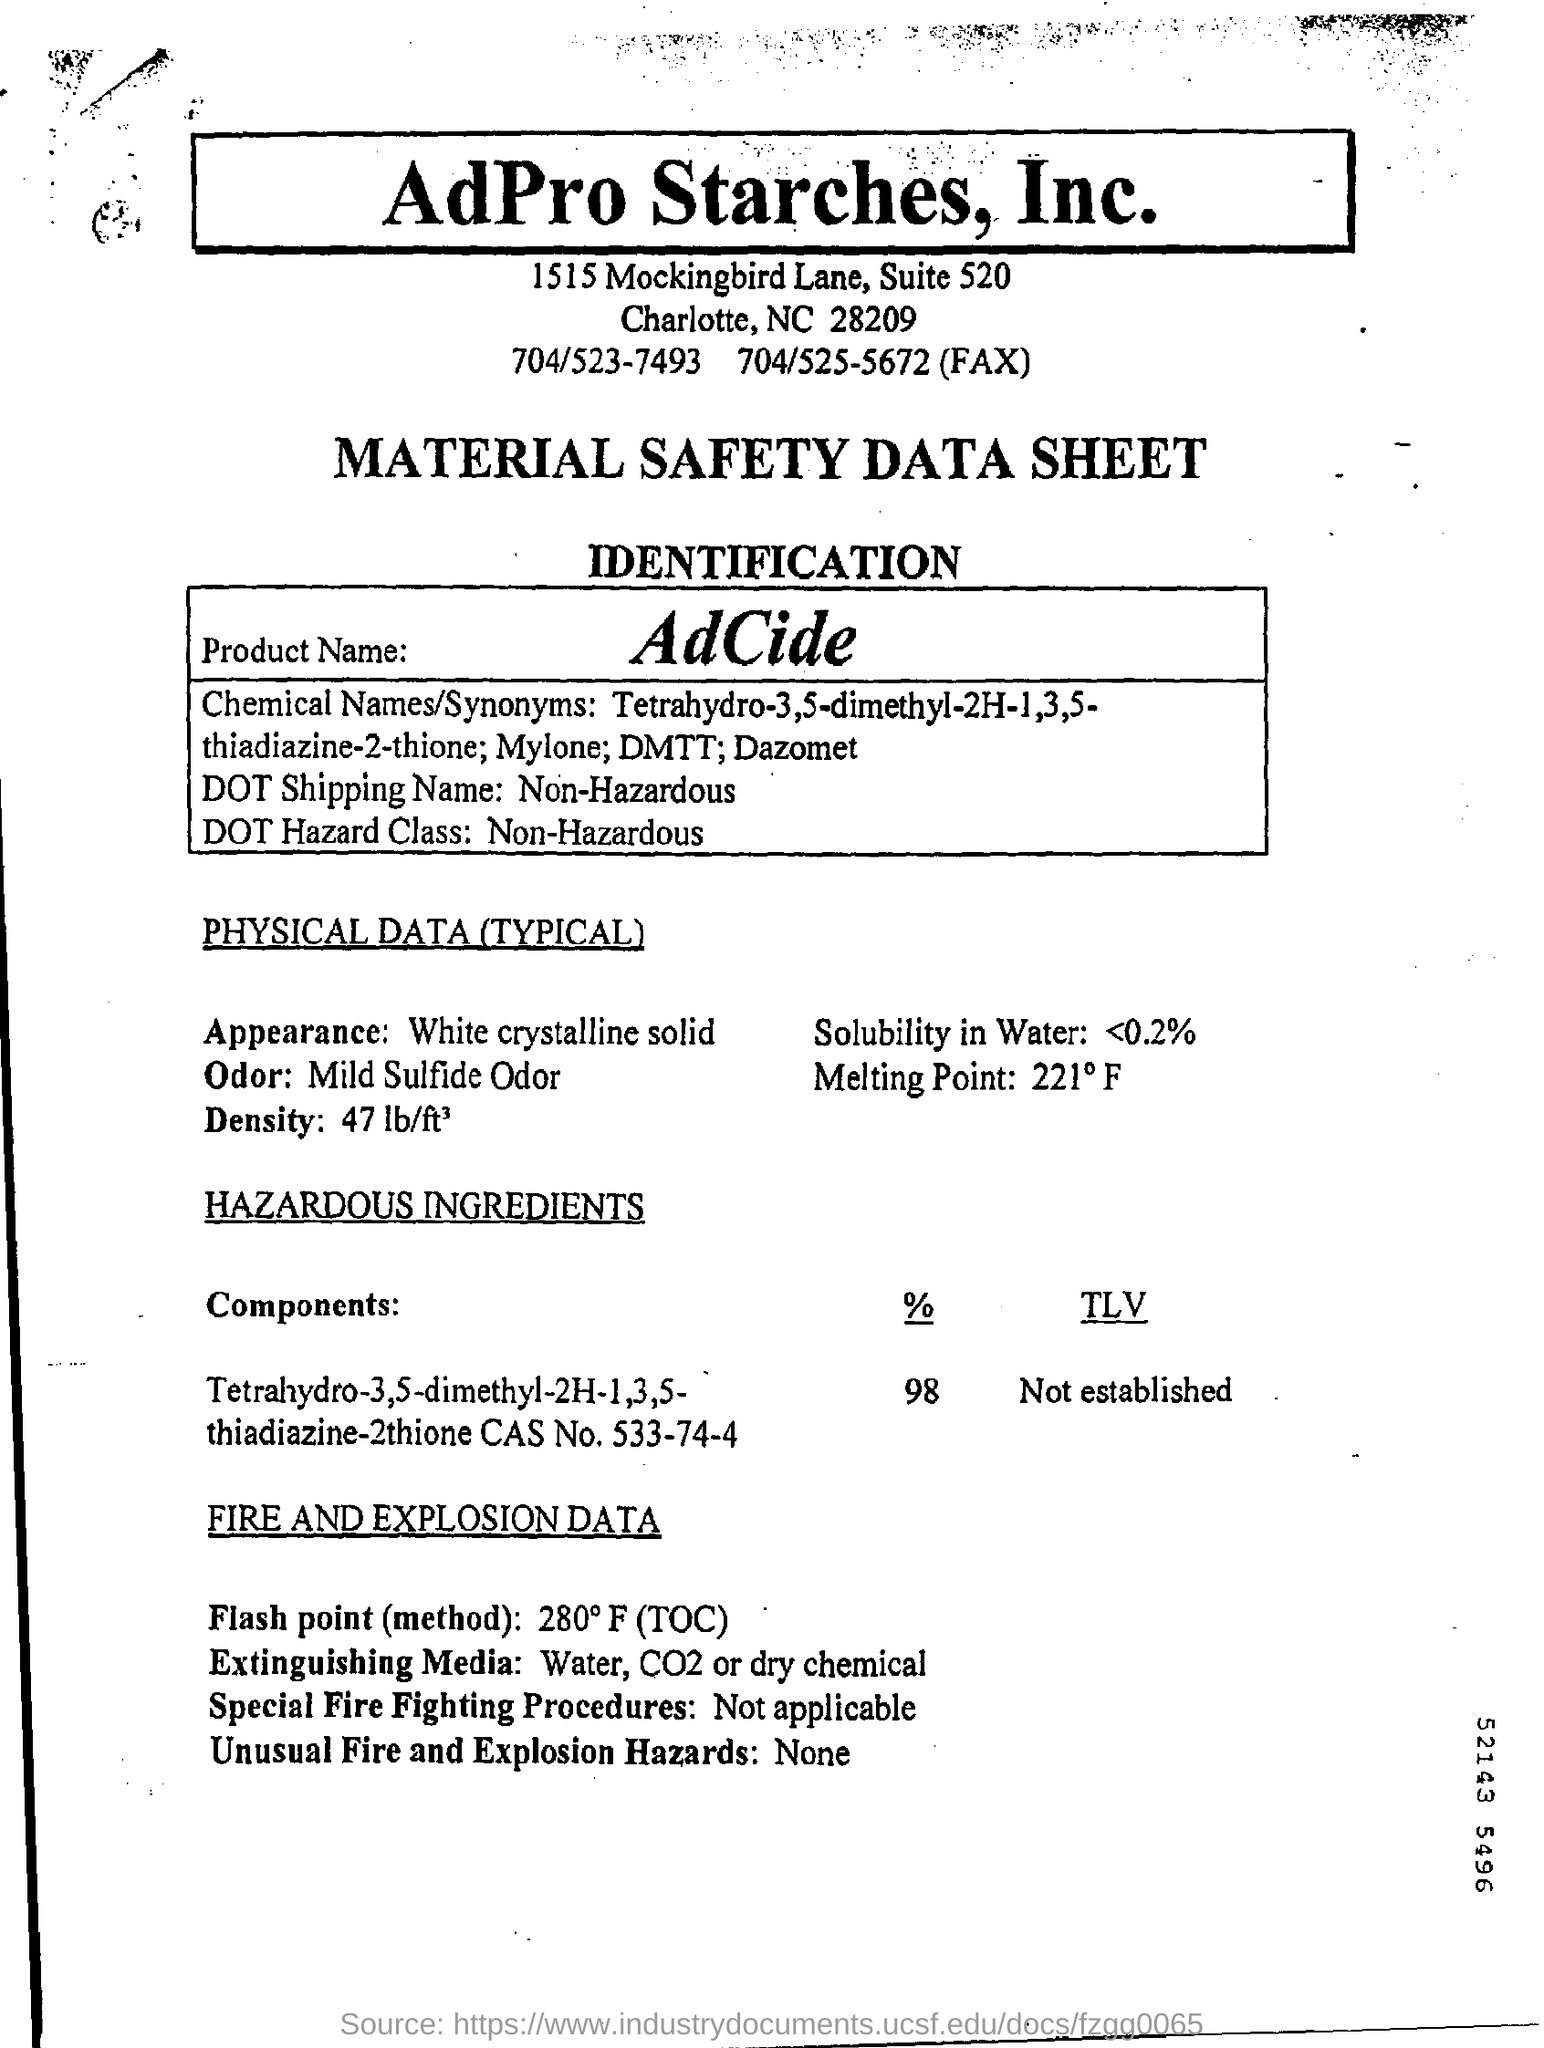Indicate a few pertinent items in this graphic. The solubility in water is less than 0.2%. AdCide is the product name. The DOT defines "Shipping Name" as "Non-Hazardous. The substance is a white crystalline solid. The DOT Hazard Class refers to a system used to categorize the potential hazards associated with transporting hazardous materials. Non-hazardous materials do not pose a significant risk to public health and safety during transportation. 